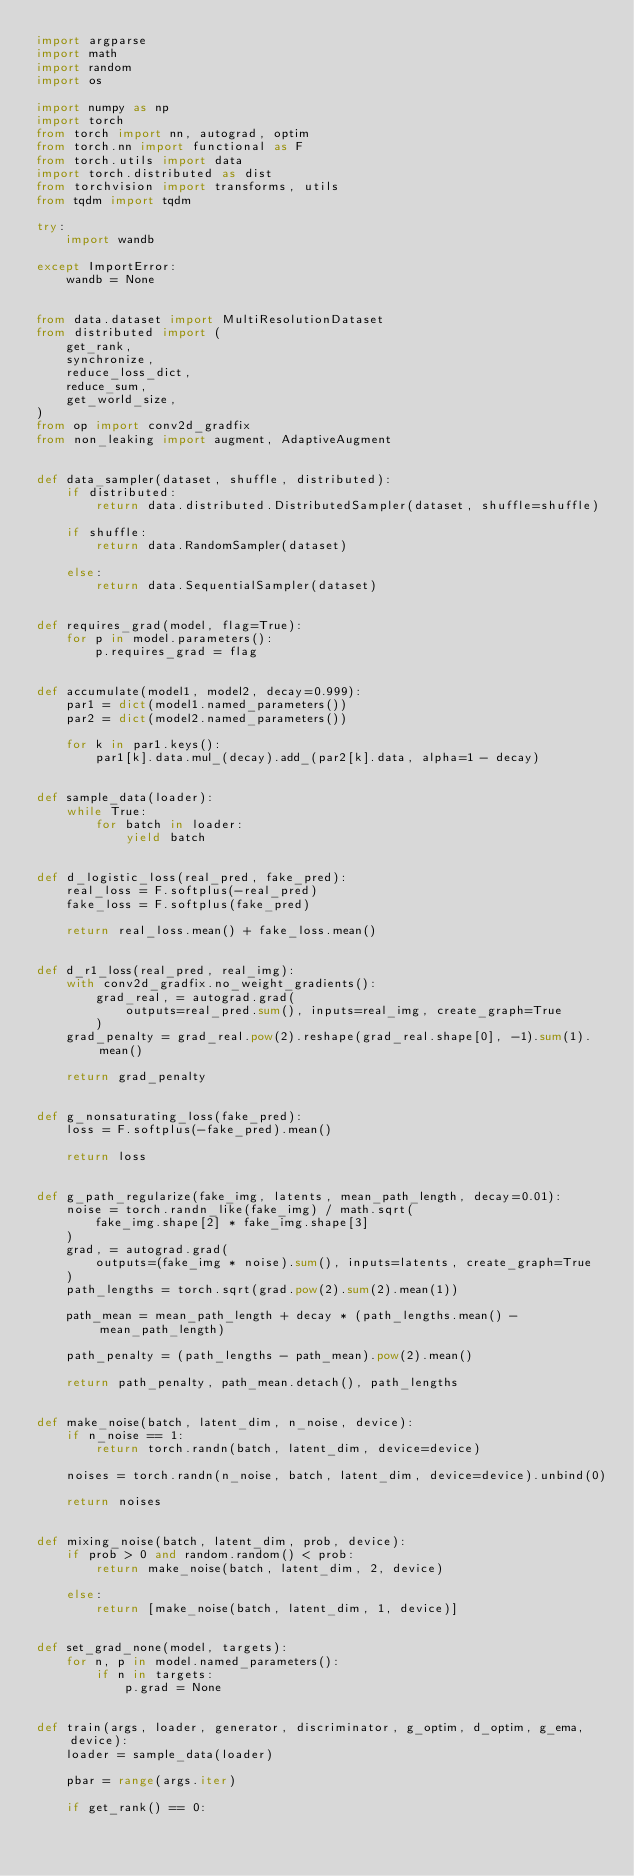<code> <loc_0><loc_0><loc_500><loc_500><_Python_>import argparse
import math
import random
import os

import numpy as np
import torch
from torch import nn, autograd, optim
from torch.nn import functional as F
from torch.utils import data
import torch.distributed as dist
from torchvision import transforms, utils
from tqdm import tqdm

try:
    import wandb

except ImportError:
    wandb = None


from data.dataset import MultiResolutionDataset
from distributed import (
    get_rank,
    synchronize,
    reduce_loss_dict,
    reduce_sum,
    get_world_size,
)
from op import conv2d_gradfix
from non_leaking import augment, AdaptiveAugment


def data_sampler(dataset, shuffle, distributed):
    if distributed:
        return data.distributed.DistributedSampler(dataset, shuffle=shuffle)

    if shuffle:
        return data.RandomSampler(dataset)

    else:
        return data.SequentialSampler(dataset)


def requires_grad(model, flag=True):
    for p in model.parameters():
        p.requires_grad = flag


def accumulate(model1, model2, decay=0.999):
    par1 = dict(model1.named_parameters())
    par2 = dict(model2.named_parameters())

    for k in par1.keys():
        par1[k].data.mul_(decay).add_(par2[k].data, alpha=1 - decay)


def sample_data(loader):
    while True:
        for batch in loader:
            yield batch


def d_logistic_loss(real_pred, fake_pred):
    real_loss = F.softplus(-real_pred)
    fake_loss = F.softplus(fake_pred)

    return real_loss.mean() + fake_loss.mean()


def d_r1_loss(real_pred, real_img):
    with conv2d_gradfix.no_weight_gradients():
        grad_real, = autograd.grad(
            outputs=real_pred.sum(), inputs=real_img, create_graph=True
        )
    grad_penalty = grad_real.pow(2).reshape(grad_real.shape[0], -1).sum(1).mean()

    return grad_penalty


def g_nonsaturating_loss(fake_pred):
    loss = F.softplus(-fake_pred).mean()

    return loss


def g_path_regularize(fake_img, latents, mean_path_length, decay=0.01):
    noise = torch.randn_like(fake_img) / math.sqrt(
        fake_img.shape[2] * fake_img.shape[3]
    )
    grad, = autograd.grad(
        outputs=(fake_img * noise).sum(), inputs=latents, create_graph=True
    )
    path_lengths = torch.sqrt(grad.pow(2).sum(2).mean(1))

    path_mean = mean_path_length + decay * (path_lengths.mean() - mean_path_length)

    path_penalty = (path_lengths - path_mean).pow(2).mean()

    return path_penalty, path_mean.detach(), path_lengths


def make_noise(batch, latent_dim, n_noise, device):
    if n_noise == 1:
        return torch.randn(batch, latent_dim, device=device)

    noises = torch.randn(n_noise, batch, latent_dim, device=device).unbind(0)

    return noises


def mixing_noise(batch, latent_dim, prob, device):
    if prob > 0 and random.random() < prob:
        return make_noise(batch, latent_dim, 2, device)

    else:
        return [make_noise(batch, latent_dim, 1, device)]


def set_grad_none(model, targets):
    for n, p in model.named_parameters():
        if n in targets:
            p.grad = None


def train(args, loader, generator, discriminator, g_optim, d_optim, g_ema, device):
    loader = sample_data(loader)

    pbar = range(args.iter)

    if get_rank() == 0:</code> 